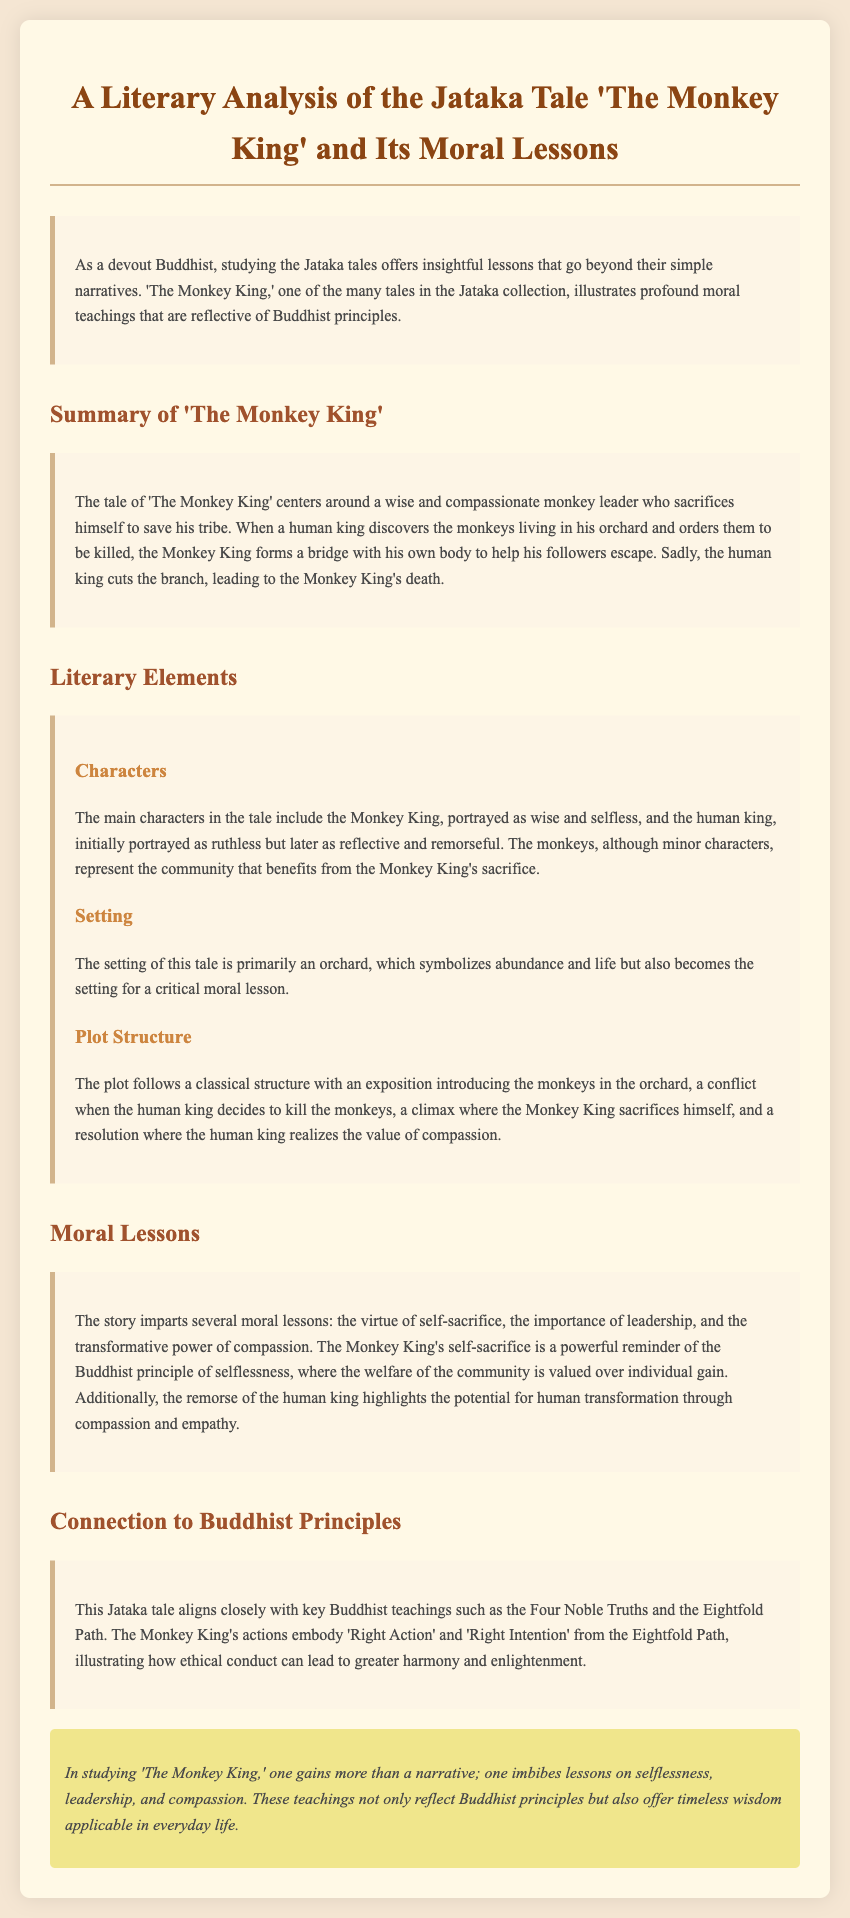What is the title of the Jataka tale discussed? The title of the Jataka tale is given in the document's heading, which states "A Literary Analysis of the Jataka Tale 'The Monkey King'."
Answer: 'The Monkey King' Who is the main character in the tale? The document specifically mentions the main character of the tale as the "Monkey King."
Answer: Monkey King What does the Monkey King do to save his tribe? The document describes that the Monkey King forms a bridge with his own body to help his followers escape.
Answer: Forms a bridge What is the setting of the tale? The setting is mentioned in the section about the "Setting," indicating that it takes place primarily in an orchard.
Answer: Orchard What moral lesson does the story emphasize? The story imparts several moral lessons, one significant lesson being the virtue of self-sacrifice.
Answer: Self-sacrifice Which principle from the Eightfold Path is illustrated by the Monkey King's actions? The document references 'Right Action' and 'Right Intention' as principles illustrated by the Monkey King's actions.
Answer: Right Action How does the human king change throughout the story? The document notes that the human king goes from being "initially portrayed as ruthless" to "reflective and remorseful."
Answer: Reflective and remorseful What broader teachings does the tale connect to? The document states that the tale aligns closely with "key Buddhist teachings such as the Four Noble Truths and the Eightfold Path."
Answer: Four Noble Truths and the Eightfold Path What final insights does the document provide? The conclusion section indicates that studying the tale provides lessons on selflessness, leadership, and compassion.
Answer: Selflessness, leadership, and compassion 